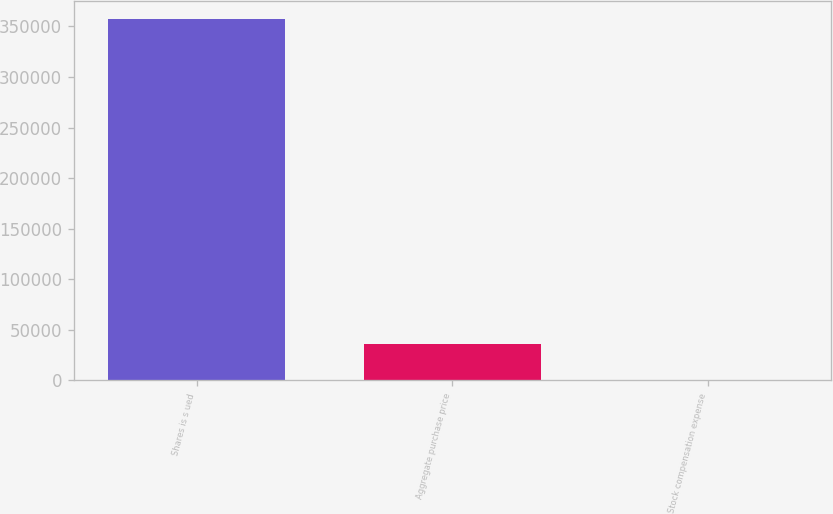<chart> <loc_0><loc_0><loc_500><loc_500><bar_chart><fcel>Shares is s ued<fcel>Aggregate purchase price<fcel>Stock compensation expense<nl><fcel>357000<fcel>35701.4<fcel>1.6<nl></chart> 